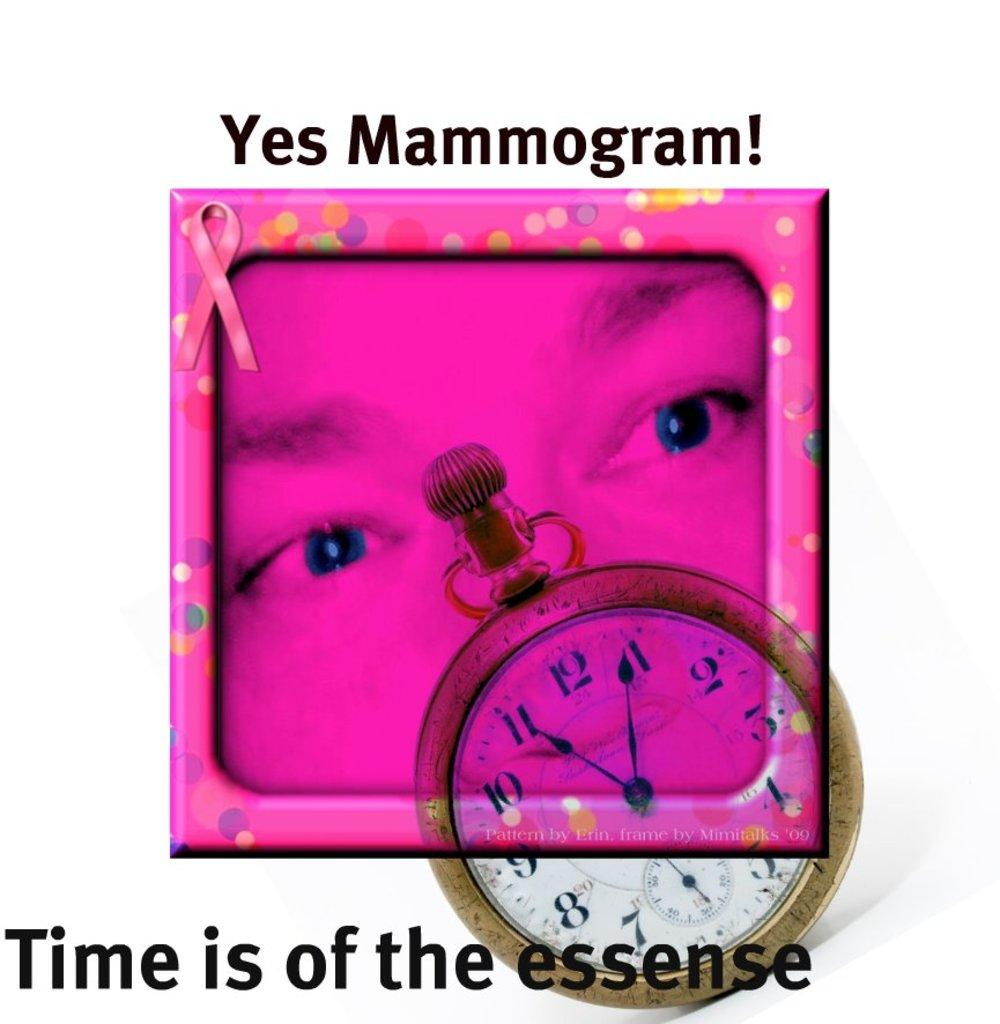What is the main object in the image? There is a frame in the image. What can be seen inside the frame? There is a clock in the image. Is there any text present in the image? Yes, there is some text in the image. What type of division is depicted in the image? There is no division present in the image; it features a frame, a clock, and some text. What sign can be seen in the image? There is no sign present in the image. 